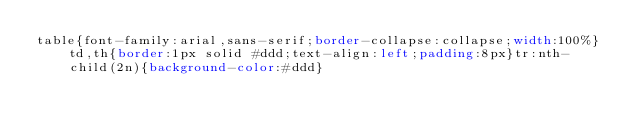<code> <loc_0><loc_0><loc_500><loc_500><_CSS_>table{font-family:arial,sans-serif;border-collapse:collapse;width:100%}td,th{border:1px solid #ddd;text-align:left;padding:8px}tr:nth-child(2n){background-color:#ddd}</code> 